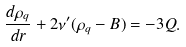Convert formula to latex. <formula><loc_0><loc_0><loc_500><loc_500>\frac { d \rho _ { q } } { d r } + 2 \nu ^ { \prime } ( \rho _ { q } - B ) = - 3 Q .</formula> 